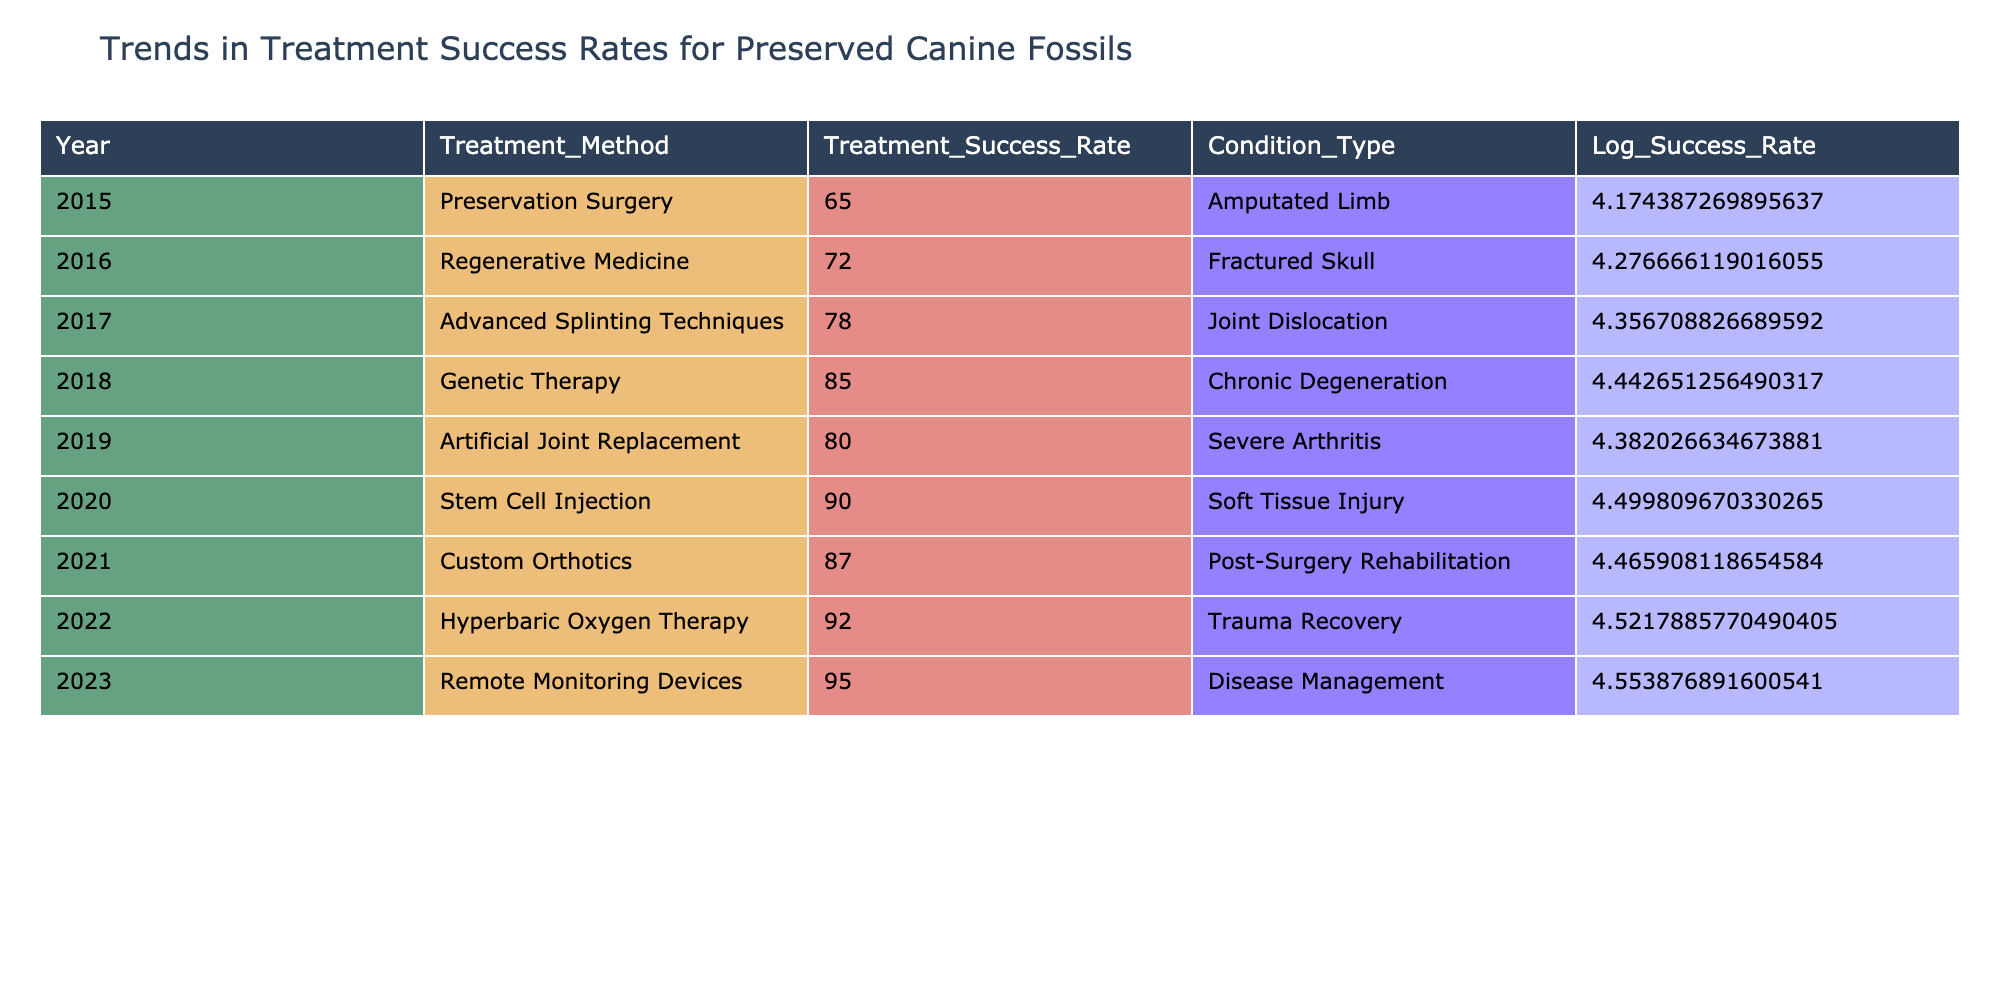What was the treatment success rate for Genetic Therapy in 2018? The table indicates that the Treatment Success Rate for Genetic Therapy in 2018 is 85.
Answer: 85 Which treatment method in 2020 had the highest treatment success rate? In 2020, the treatment method was Stem Cell Injection, which had a treatment success rate of 90, the highest in that year.
Answer: Stem Cell Injection What is the average treatment success rate for the years 2015 to 2019? Sum the treatment success rates: 65 + 72 + 78 + 85 + 80 = 380. Divide by 5 (the number of years): 380 / 5 = 76.
Answer: 76 Did the treatment success rate improve from 2015 to 2023? Comparing 2015's success rate of 65 with 2023's rate of 95 shows a clear increase. Therefore, yes, the treatment success rate improved.
Answer: Yes What is the difference in treatment success rates between Hyperbaric Oxygen Therapy in 2022 and Artificial Joint Replacement in 2019? Hyperbaric Oxygen Therapy had a success rate of 92, and Artificial Joint Replacement had a rate of 80. The difference is 92 - 80 = 12.
Answer: 12 Which condition type had the lowest treatment success rate in 2016? The table shows that Fractured Skull (treated with Regenerative Medicine) had a success rate of 72 in 2016, which is the only value listed for that year.
Answer: 72 What trend can be observed in treatment methods regarding success rates from 2015 to 2023? The table reveals a consistent upward trend in treatment success rates from 65 in 2015 to 95 in 2023, indicating improvements over time in treatment efficacy.
Answer: Upward trend How many treatment methods surpassed a 90% success rate? The table lists two treatments: Stem Cell Injection in 2020 (90) and Remote Monitoring Devices in 2023 (95), giving a total of 2 methods with success rates over 90%.
Answer: 2 What was the treatment success rate for Custom Orthotics in 2021? According to the table, the Treatment Success Rate for Custom Orthotics in 2021 is 87.
Answer: 87 